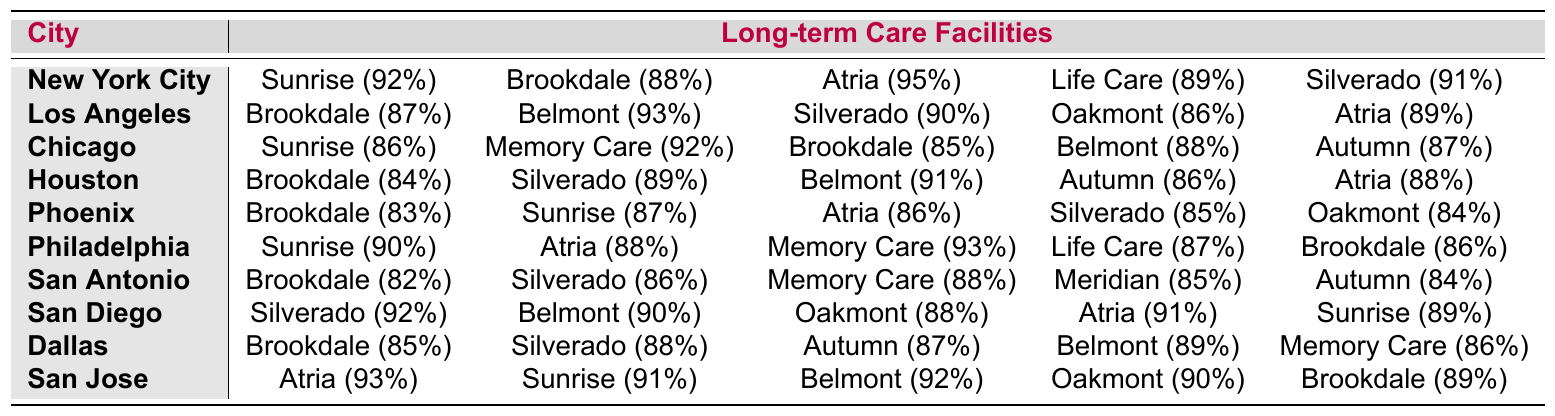What is the highest occupancy rate for long-term care facilities in New York City? Referring to the New York City row, the highest occupancy rate is found in Atria Senior Living at 95%.
Answer: 95% Which city has the lowest occupancy rate for Brookdale Senior Living? Looking at the Brookdale Senior Living occupancy rates across the cities, Houston has the lowest rate at 84%.
Answer: 84% What is the average occupancy rate for facilities in San Diego? The occupancy rates for San Diego are (92 + 90 + 88 + 91 + 89) = 450, and there are 5 facilities, so the average is 450/5 = 90.
Answer: 90 Is there a facility in San Antonio that has an occupancy rate above 90%? Checking the occupancy rates for San Antonio, the highest rate is 88% for Memory Care Living, which is below 90%.
Answer: No Which facility has the highest occupancy rate in San Jose? In the San Jose row, Atria Senior Living has the highest occupancy rate at 93%.
Answer: 93% What is the difference between the highest and lowest occupancy rates for long-term care facilities in Los Angeles? The highest rate in Los Angeles is Belmont Village at 93%, and the lowest is Oakmont Senior Living at 86%. The difference is 93 - 86 = 7.
Answer: 7 How many cities have a facility with an occupancy rate of at least 90%? By examining the table, the cities with rates of 90% and above are New York City (Atria), Philadelphia (Memory Care Living), San Diego (Silverado Care), and San Jose (Atria). That's a total of 4 cities.
Answer: 4 Which facility has the same occupancy rate in both Phoenix and Chicago? Looking at both rows, Atria Senior Living has an occupancy rate of 86% in Phoenix and 87% in Chicago, while no facility shares the same occupancy rate in both cities.
Answer: None Identify the city with the highest occupancy rate for Silverado Care. Silverado Care has the highest occupancy rate of 92% in San Diego compared to other cities.
Answer: San Diego What is the total occupancy percentage for all the facilities in Dallas? The sum of occupancy rates in Dallas is (85 + 88 + 87 + 89 + 86) = 435.
Answer: 435 Which metropolitan area has the highest overall range between its highest and lowest occupancy rates for facilities? The range can be calculated by finding the maximum and minimum occupancy rates for each city. After calculating, the maximum range is found in San Antonio, with 88% - 82% = 6%.
Answer: San Antonio 